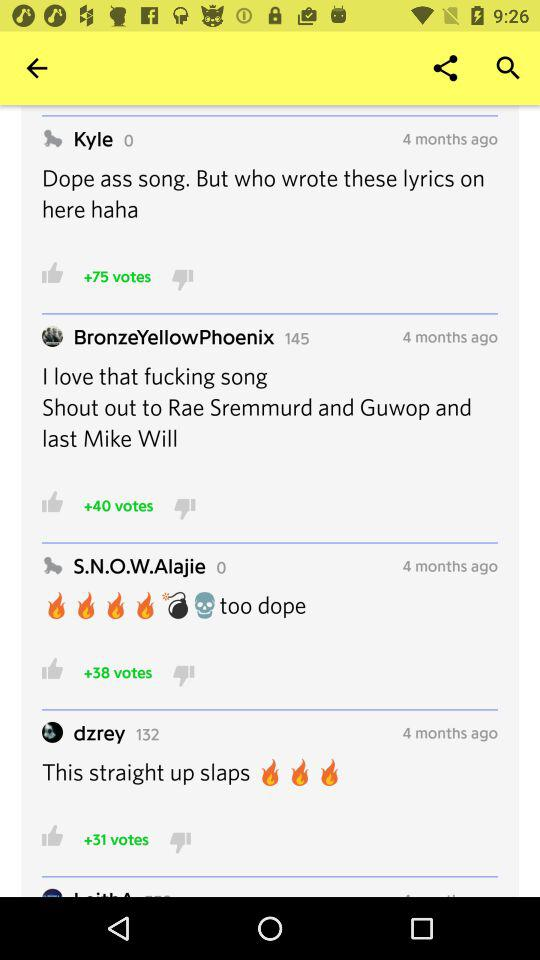How many thumbs up votes does the first comment have?
Answer the question using a single word or phrase. 75 